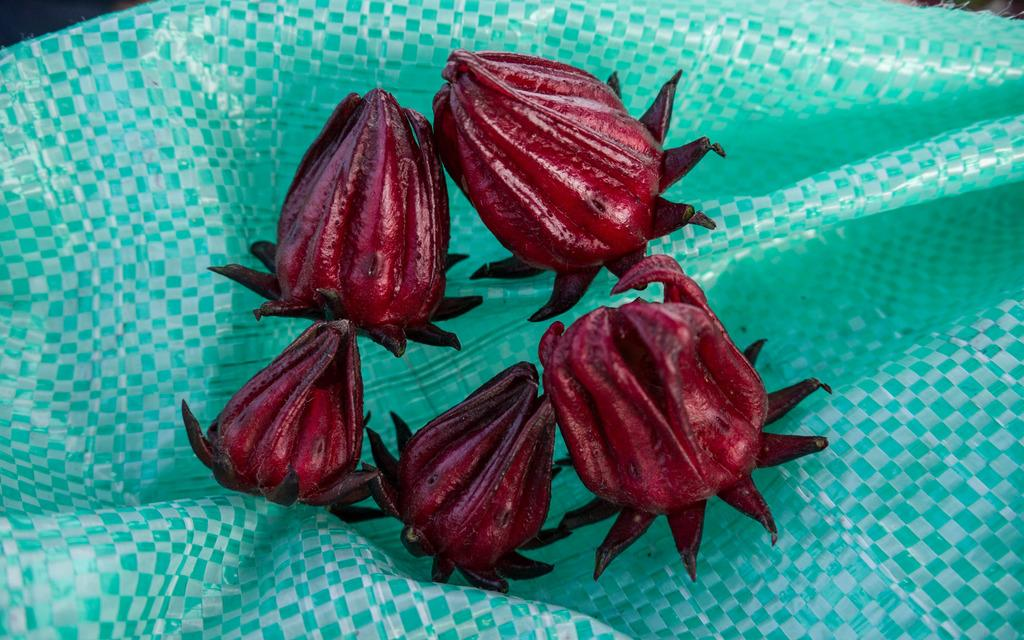What is depicted on the cover in the image? There are flowers on the cover in the image. Can you see a duck holding an umbrella under a bun in the image? There is no duck, umbrella, or bun present in the image. 